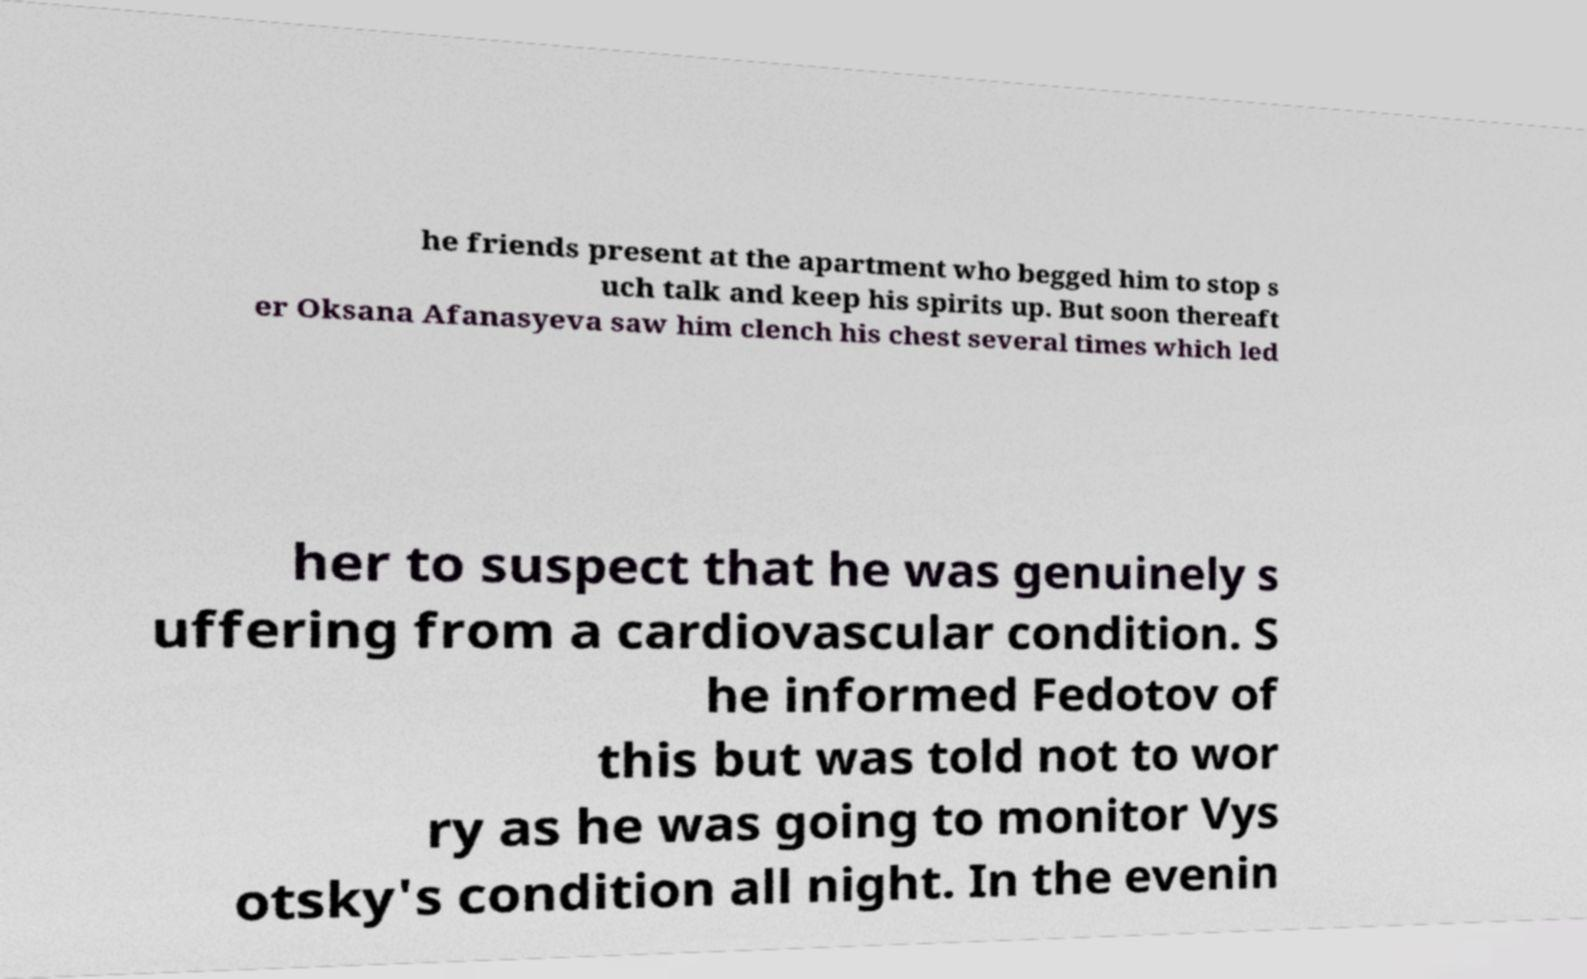For documentation purposes, I need the text within this image transcribed. Could you provide that? he friends present at the apartment who begged him to stop s uch talk and keep his spirits up. But soon thereaft er Oksana Afanasyeva saw him clench his chest several times which led her to suspect that he was genuinely s uffering from a cardiovascular condition. S he informed Fedotov of this but was told not to wor ry as he was going to monitor Vys otsky's condition all night. In the evenin 